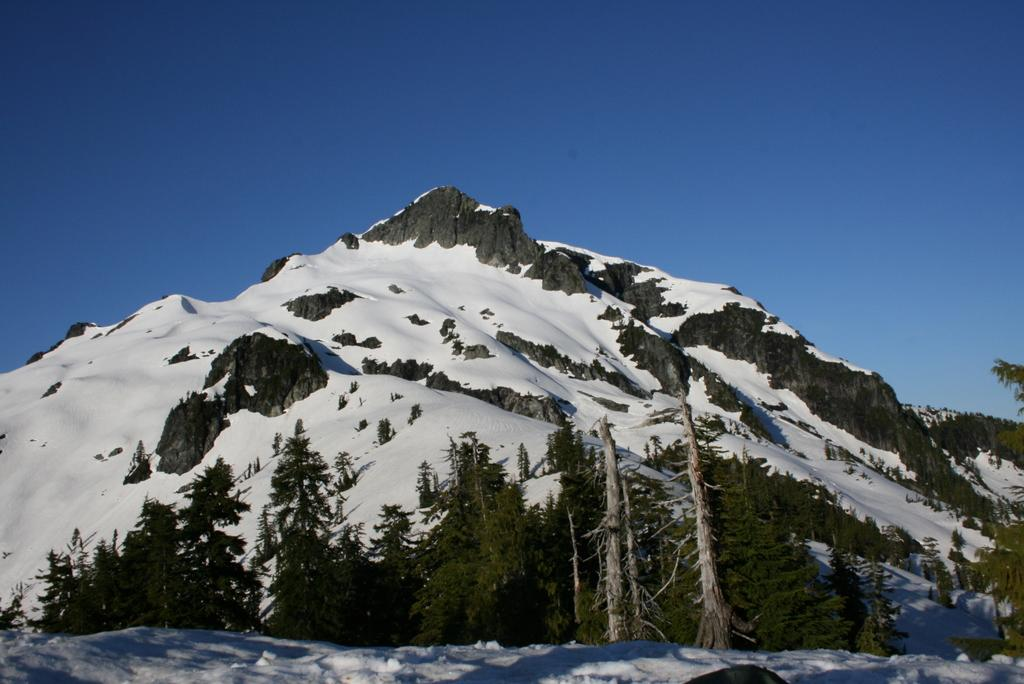What type of vegetation is at the bottom of the image? There are trees at the bottom side of the image. What geographical feature is in the center of the image? There are mountains in the center of the image. What is the weather condition on the mountains? There is snow on the mountains, indicating a cold or snowy condition. Where are the apples being stored by the giants in the image? There are no apples or giants present in the image. What type of waste can be seen at the bottom of the image? There is no waste present in the image; it features trees at the bottom side. 